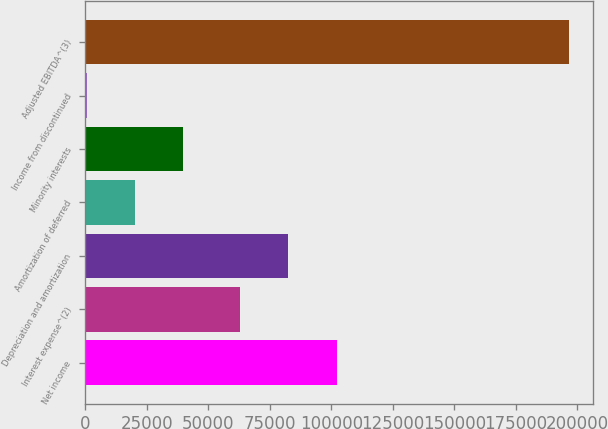Convert chart to OTSL. <chart><loc_0><loc_0><loc_500><loc_500><bar_chart><fcel>Net income<fcel>Interest expense^(2)<fcel>Depreciation and amortization<fcel>Amortization of deferred<fcel>Minority interests<fcel>Income from discontinued<fcel>Adjusted EBITDA^(3)<nl><fcel>102198<fcel>63023<fcel>82610.6<fcel>20304.6<fcel>39892.2<fcel>717<fcel>196593<nl></chart> 